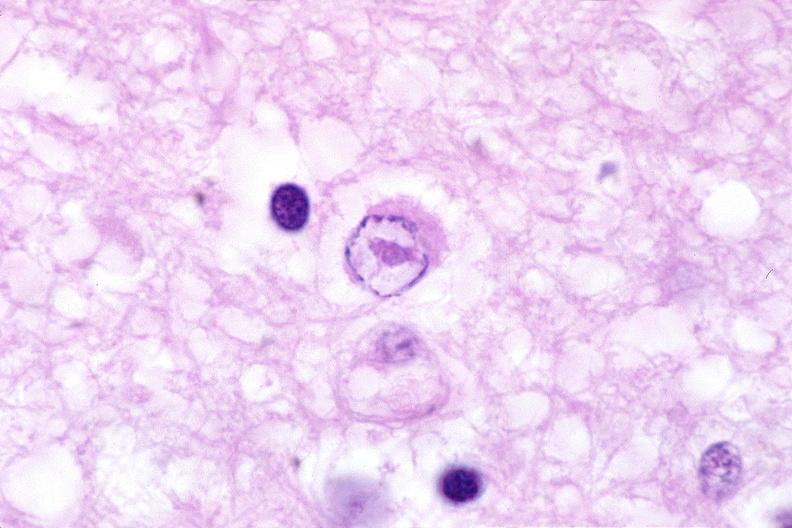does anthracotic pigment show brain, herpes encephalitis with inclusion bodies?
Answer the question using a single word or phrase. No 